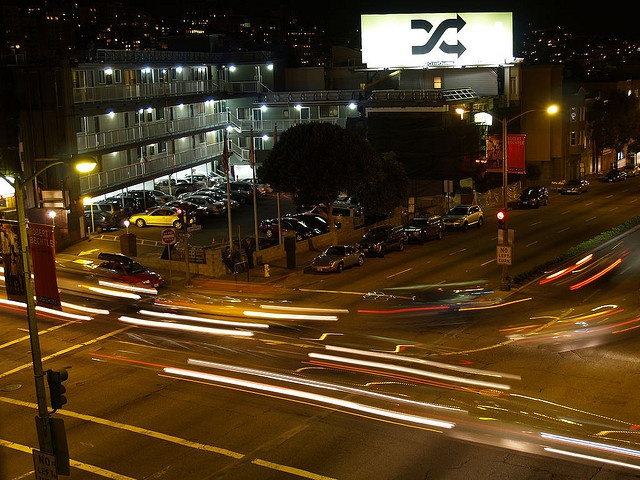Describe the objects in this image and their specific colors. I can see car in black, maroon, olive, and gray tones, car in black, maroon, and gray tones, car in black, maroon, and gray tones, car in black, gold, orange, and maroon tones, and car in black, gray, maroon, and olive tones in this image. 